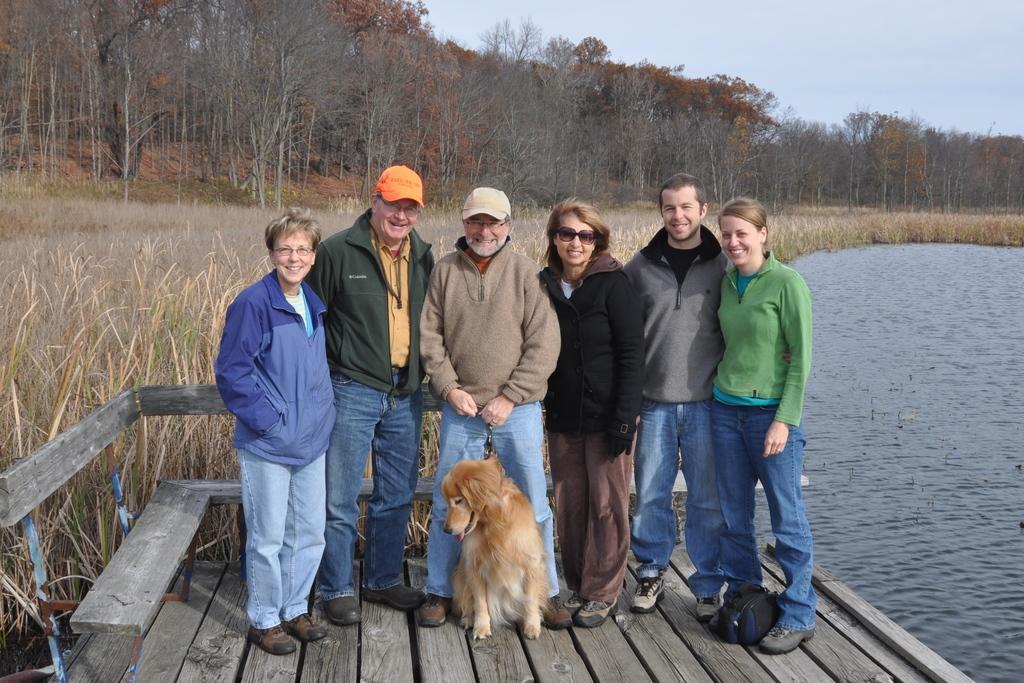How would you summarize this image in a sentence or two? In this picture we can see people standing on a wooden platform with dog and they are smiling and in background we can see trees, water, grass. 